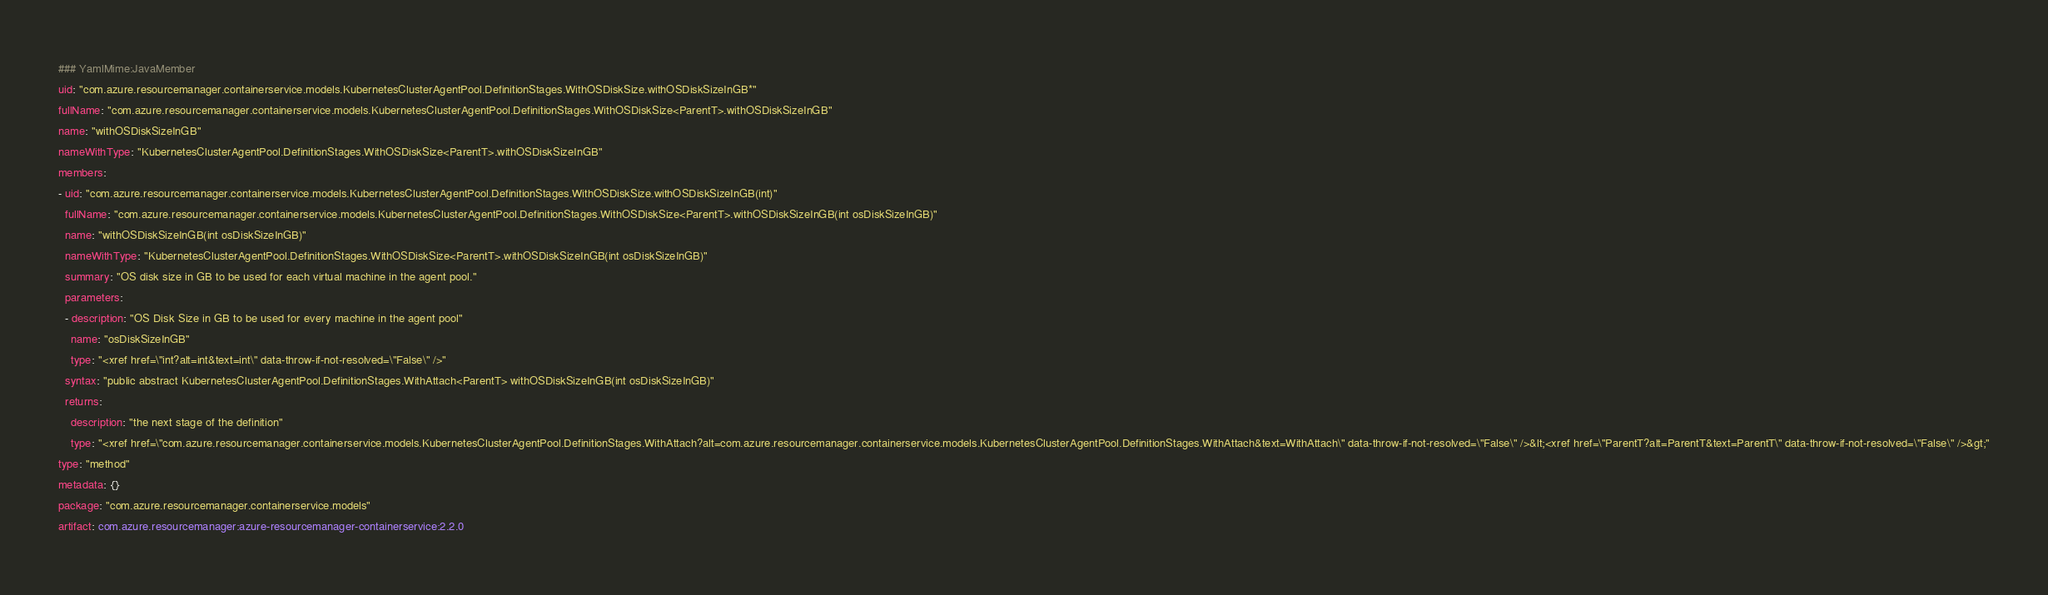<code> <loc_0><loc_0><loc_500><loc_500><_YAML_>### YamlMime:JavaMember
uid: "com.azure.resourcemanager.containerservice.models.KubernetesClusterAgentPool.DefinitionStages.WithOSDiskSize.withOSDiskSizeInGB*"
fullName: "com.azure.resourcemanager.containerservice.models.KubernetesClusterAgentPool.DefinitionStages.WithOSDiskSize<ParentT>.withOSDiskSizeInGB"
name: "withOSDiskSizeInGB"
nameWithType: "KubernetesClusterAgentPool.DefinitionStages.WithOSDiskSize<ParentT>.withOSDiskSizeInGB"
members:
- uid: "com.azure.resourcemanager.containerservice.models.KubernetesClusterAgentPool.DefinitionStages.WithOSDiskSize.withOSDiskSizeInGB(int)"
  fullName: "com.azure.resourcemanager.containerservice.models.KubernetesClusterAgentPool.DefinitionStages.WithOSDiskSize<ParentT>.withOSDiskSizeInGB(int osDiskSizeInGB)"
  name: "withOSDiskSizeInGB(int osDiskSizeInGB)"
  nameWithType: "KubernetesClusterAgentPool.DefinitionStages.WithOSDiskSize<ParentT>.withOSDiskSizeInGB(int osDiskSizeInGB)"
  summary: "OS disk size in GB to be used for each virtual machine in the agent pool."
  parameters:
  - description: "OS Disk Size in GB to be used for every machine in the agent pool"
    name: "osDiskSizeInGB"
    type: "<xref href=\"int?alt=int&text=int\" data-throw-if-not-resolved=\"False\" />"
  syntax: "public abstract KubernetesClusterAgentPool.DefinitionStages.WithAttach<ParentT> withOSDiskSizeInGB(int osDiskSizeInGB)"
  returns:
    description: "the next stage of the definition"
    type: "<xref href=\"com.azure.resourcemanager.containerservice.models.KubernetesClusterAgentPool.DefinitionStages.WithAttach?alt=com.azure.resourcemanager.containerservice.models.KubernetesClusterAgentPool.DefinitionStages.WithAttach&text=WithAttach\" data-throw-if-not-resolved=\"False\" />&lt;<xref href=\"ParentT?alt=ParentT&text=ParentT\" data-throw-if-not-resolved=\"False\" />&gt;"
type: "method"
metadata: {}
package: "com.azure.resourcemanager.containerservice.models"
artifact: com.azure.resourcemanager:azure-resourcemanager-containerservice:2.2.0
</code> 